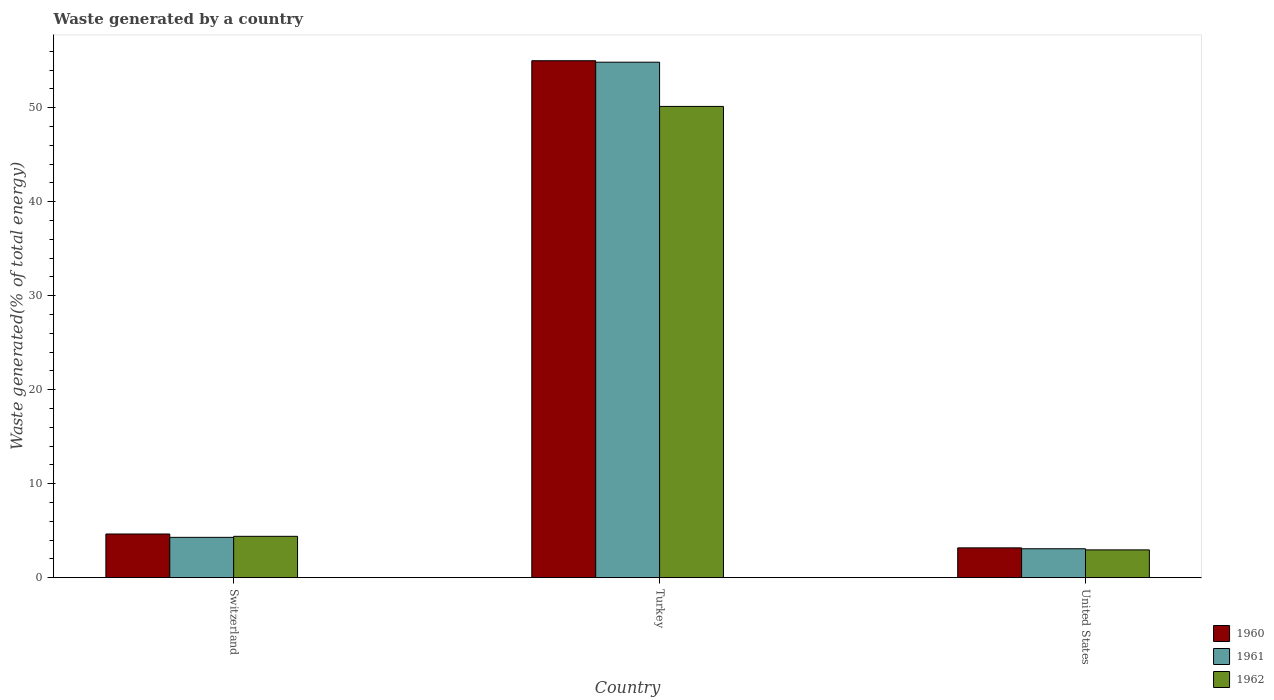How many different coloured bars are there?
Provide a short and direct response. 3. In how many cases, is the number of bars for a given country not equal to the number of legend labels?
Offer a terse response. 0. What is the total waste generated in 1960 in Switzerland?
Keep it short and to the point. 4.65. Across all countries, what is the maximum total waste generated in 1961?
Ensure brevity in your answer.  54.84. Across all countries, what is the minimum total waste generated in 1961?
Provide a short and direct response. 3.08. In which country was the total waste generated in 1962 maximum?
Offer a very short reply. Turkey. In which country was the total waste generated in 1960 minimum?
Provide a short and direct response. United States. What is the total total waste generated in 1962 in the graph?
Your answer should be compact. 57.5. What is the difference between the total waste generated in 1961 in Turkey and that in United States?
Your response must be concise. 51.76. What is the difference between the total waste generated in 1960 in Turkey and the total waste generated in 1962 in Switzerland?
Provide a short and direct response. 50.59. What is the average total waste generated in 1961 per country?
Provide a short and direct response. 20.74. What is the difference between the total waste generated of/in 1960 and total waste generated of/in 1962 in Turkey?
Your answer should be very brief. 4.86. In how many countries, is the total waste generated in 1960 greater than 52 %?
Give a very brief answer. 1. What is the ratio of the total waste generated in 1961 in Turkey to that in United States?
Ensure brevity in your answer.  17.81. What is the difference between the highest and the second highest total waste generated in 1960?
Offer a terse response. -1.48. What is the difference between the highest and the lowest total waste generated in 1962?
Your answer should be very brief. 47.17. What does the 2nd bar from the left in United States represents?
Make the answer very short. 1961. What does the 3rd bar from the right in Switzerland represents?
Provide a succinct answer. 1960. Are all the bars in the graph horizontal?
Ensure brevity in your answer.  No. How many countries are there in the graph?
Provide a short and direct response. 3. Are the values on the major ticks of Y-axis written in scientific E-notation?
Provide a succinct answer. No. Does the graph contain any zero values?
Ensure brevity in your answer.  No. Does the graph contain grids?
Your answer should be compact. No. How many legend labels are there?
Your answer should be very brief. 3. What is the title of the graph?
Give a very brief answer. Waste generated by a country. What is the label or title of the X-axis?
Your answer should be very brief. Country. What is the label or title of the Y-axis?
Make the answer very short. Waste generated(% of total energy). What is the Waste generated(% of total energy) in 1960 in Switzerland?
Ensure brevity in your answer.  4.65. What is the Waste generated(% of total energy) in 1961 in Switzerland?
Keep it short and to the point. 4.29. What is the Waste generated(% of total energy) of 1962 in Switzerland?
Your answer should be compact. 4.4. What is the Waste generated(% of total energy) in 1960 in Turkey?
Ensure brevity in your answer.  54.99. What is the Waste generated(% of total energy) of 1961 in Turkey?
Your response must be concise. 54.84. What is the Waste generated(% of total energy) of 1962 in Turkey?
Make the answer very short. 50.13. What is the Waste generated(% of total energy) in 1960 in United States?
Your answer should be very brief. 3.17. What is the Waste generated(% of total energy) in 1961 in United States?
Make the answer very short. 3.08. What is the Waste generated(% of total energy) of 1962 in United States?
Keep it short and to the point. 2.96. Across all countries, what is the maximum Waste generated(% of total energy) in 1960?
Give a very brief answer. 54.99. Across all countries, what is the maximum Waste generated(% of total energy) of 1961?
Keep it short and to the point. 54.84. Across all countries, what is the maximum Waste generated(% of total energy) in 1962?
Provide a succinct answer. 50.13. Across all countries, what is the minimum Waste generated(% of total energy) in 1960?
Keep it short and to the point. 3.17. Across all countries, what is the minimum Waste generated(% of total energy) of 1961?
Your answer should be compact. 3.08. Across all countries, what is the minimum Waste generated(% of total energy) of 1962?
Offer a very short reply. 2.96. What is the total Waste generated(% of total energy) in 1960 in the graph?
Give a very brief answer. 62.82. What is the total Waste generated(% of total energy) in 1961 in the graph?
Provide a succinct answer. 62.21. What is the total Waste generated(% of total energy) in 1962 in the graph?
Your response must be concise. 57.5. What is the difference between the Waste generated(% of total energy) in 1960 in Switzerland and that in Turkey?
Your response must be concise. -50.34. What is the difference between the Waste generated(% of total energy) of 1961 in Switzerland and that in Turkey?
Offer a very short reply. -50.55. What is the difference between the Waste generated(% of total energy) in 1962 in Switzerland and that in Turkey?
Make the answer very short. -45.73. What is the difference between the Waste generated(% of total energy) in 1960 in Switzerland and that in United States?
Your answer should be compact. 1.48. What is the difference between the Waste generated(% of total energy) in 1961 in Switzerland and that in United States?
Your answer should be very brief. 1.21. What is the difference between the Waste generated(% of total energy) in 1962 in Switzerland and that in United States?
Ensure brevity in your answer.  1.44. What is the difference between the Waste generated(% of total energy) in 1960 in Turkey and that in United States?
Offer a terse response. 51.82. What is the difference between the Waste generated(% of total energy) of 1961 in Turkey and that in United States?
Make the answer very short. 51.76. What is the difference between the Waste generated(% of total energy) in 1962 in Turkey and that in United States?
Offer a very short reply. 47.17. What is the difference between the Waste generated(% of total energy) of 1960 in Switzerland and the Waste generated(% of total energy) of 1961 in Turkey?
Offer a terse response. -50.19. What is the difference between the Waste generated(% of total energy) in 1960 in Switzerland and the Waste generated(% of total energy) in 1962 in Turkey?
Ensure brevity in your answer.  -45.48. What is the difference between the Waste generated(% of total energy) of 1961 in Switzerland and the Waste generated(% of total energy) of 1962 in Turkey?
Make the answer very short. -45.84. What is the difference between the Waste generated(% of total energy) in 1960 in Switzerland and the Waste generated(% of total energy) in 1961 in United States?
Your response must be concise. 1.57. What is the difference between the Waste generated(% of total energy) of 1960 in Switzerland and the Waste generated(% of total energy) of 1962 in United States?
Ensure brevity in your answer.  1.69. What is the difference between the Waste generated(% of total energy) in 1961 in Switzerland and the Waste generated(% of total energy) in 1962 in United States?
Your response must be concise. 1.33. What is the difference between the Waste generated(% of total energy) in 1960 in Turkey and the Waste generated(% of total energy) in 1961 in United States?
Make the answer very short. 51.92. What is the difference between the Waste generated(% of total energy) in 1960 in Turkey and the Waste generated(% of total energy) in 1962 in United States?
Make the answer very short. 52.03. What is the difference between the Waste generated(% of total energy) in 1961 in Turkey and the Waste generated(% of total energy) in 1962 in United States?
Your answer should be very brief. 51.88. What is the average Waste generated(% of total energy) of 1960 per country?
Your answer should be compact. 20.94. What is the average Waste generated(% of total energy) of 1961 per country?
Provide a succinct answer. 20.74. What is the average Waste generated(% of total energy) in 1962 per country?
Offer a terse response. 19.17. What is the difference between the Waste generated(% of total energy) in 1960 and Waste generated(% of total energy) in 1961 in Switzerland?
Provide a succinct answer. 0.36. What is the difference between the Waste generated(% of total energy) in 1960 and Waste generated(% of total energy) in 1962 in Switzerland?
Make the answer very short. 0.25. What is the difference between the Waste generated(% of total energy) of 1961 and Waste generated(% of total energy) of 1962 in Switzerland?
Offer a very short reply. -0.11. What is the difference between the Waste generated(% of total energy) of 1960 and Waste generated(% of total energy) of 1961 in Turkey?
Your answer should be very brief. 0.16. What is the difference between the Waste generated(% of total energy) of 1960 and Waste generated(% of total energy) of 1962 in Turkey?
Provide a succinct answer. 4.86. What is the difference between the Waste generated(% of total energy) of 1961 and Waste generated(% of total energy) of 1962 in Turkey?
Your response must be concise. 4.7. What is the difference between the Waste generated(% of total energy) of 1960 and Waste generated(% of total energy) of 1961 in United States?
Keep it short and to the point. 0.1. What is the difference between the Waste generated(% of total energy) in 1960 and Waste generated(% of total energy) in 1962 in United States?
Ensure brevity in your answer.  0.21. What is the difference between the Waste generated(% of total energy) in 1961 and Waste generated(% of total energy) in 1962 in United States?
Offer a terse response. 0.12. What is the ratio of the Waste generated(% of total energy) of 1960 in Switzerland to that in Turkey?
Your answer should be compact. 0.08. What is the ratio of the Waste generated(% of total energy) of 1961 in Switzerland to that in Turkey?
Ensure brevity in your answer.  0.08. What is the ratio of the Waste generated(% of total energy) in 1962 in Switzerland to that in Turkey?
Your answer should be very brief. 0.09. What is the ratio of the Waste generated(% of total energy) of 1960 in Switzerland to that in United States?
Your response must be concise. 1.46. What is the ratio of the Waste generated(% of total energy) in 1961 in Switzerland to that in United States?
Provide a succinct answer. 1.39. What is the ratio of the Waste generated(% of total energy) of 1962 in Switzerland to that in United States?
Offer a very short reply. 1.49. What is the ratio of the Waste generated(% of total energy) in 1960 in Turkey to that in United States?
Your answer should be compact. 17.32. What is the ratio of the Waste generated(% of total energy) of 1961 in Turkey to that in United States?
Provide a short and direct response. 17.81. What is the ratio of the Waste generated(% of total energy) in 1962 in Turkey to that in United States?
Ensure brevity in your answer.  16.94. What is the difference between the highest and the second highest Waste generated(% of total energy) in 1960?
Your answer should be very brief. 50.34. What is the difference between the highest and the second highest Waste generated(% of total energy) in 1961?
Give a very brief answer. 50.55. What is the difference between the highest and the second highest Waste generated(% of total energy) in 1962?
Your answer should be very brief. 45.73. What is the difference between the highest and the lowest Waste generated(% of total energy) in 1960?
Your response must be concise. 51.82. What is the difference between the highest and the lowest Waste generated(% of total energy) in 1961?
Your answer should be very brief. 51.76. What is the difference between the highest and the lowest Waste generated(% of total energy) of 1962?
Your response must be concise. 47.17. 